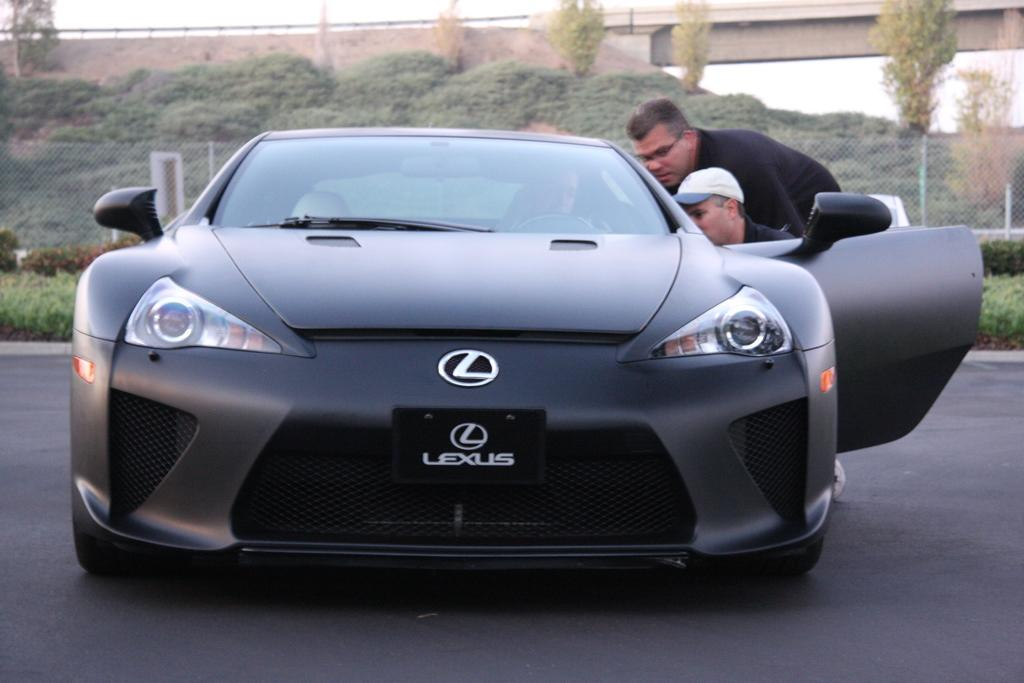How many people are in the image? There are two men in the image. What are the men doing in the image? The men are beside a car. What can be seen in the background of the image? There are trees, a bridge, and a fence in the background of the image. What type of brush is the man using to paint the back of the car in the image? There is no brush or painting activity present in the image; the men are simply standing beside the car. 